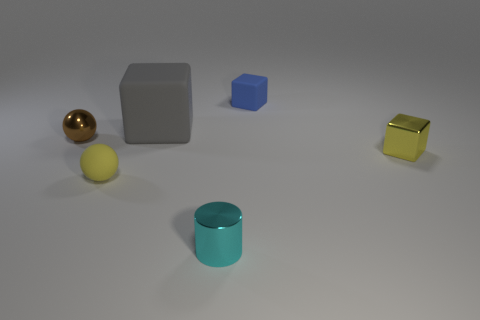Do the matte sphere and the shiny block have the same color?
Your response must be concise. Yes. There is a tiny matte thing in front of the gray rubber block; is it the same color as the tiny shiny block?
Your answer should be very brief. Yes. What number of tiny brown objects are made of the same material as the cyan object?
Ensure brevity in your answer.  1. The brown metal object that is the same shape as the yellow rubber thing is what size?
Your answer should be compact. Small. There is a yellow object to the left of the small cylinder; does it have the same shape as the big gray thing?
Make the answer very short. No. The small matte object that is to the left of the object behind the gray rubber thing is what shape?
Your answer should be very brief. Sphere. Is there any other thing that has the same shape as the brown metallic object?
Make the answer very short. Yes. What is the color of the other matte thing that is the same shape as the gray rubber object?
Your response must be concise. Blue. Do the large thing and the small object behind the brown ball have the same color?
Ensure brevity in your answer.  No. What shape is the small shiny object that is both to the left of the small matte cube and in front of the brown shiny ball?
Offer a terse response. Cylinder. 